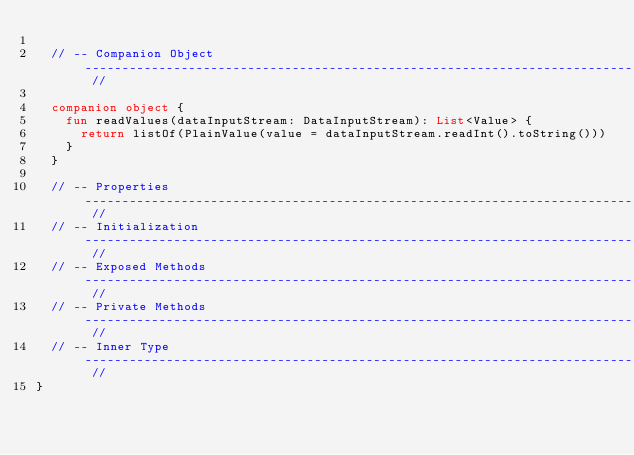Convert code to text. <code><loc_0><loc_0><loc_500><loc_500><_Kotlin_>
  // -- Companion Object -------------------------------------------------------------------------------------------- //

  companion object {
    fun readValues(dataInputStream: DataInputStream): List<Value> {
      return listOf(PlainValue(value = dataInputStream.readInt().toString()))
    }
  }

  // -- Properties -------------------------------------------------------------------------------------------------- //
  // -- Initialization ---------------------------------------------------------------------------------------------- //
  // -- Exposed Methods --------------------------------------------------------------------------------------------- //
  // -- Private Methods --------------------------------------------------------------------------------------------- //
  // -- Inner Type -------------------------------------------------------------------------------------------------- //
}</code> 